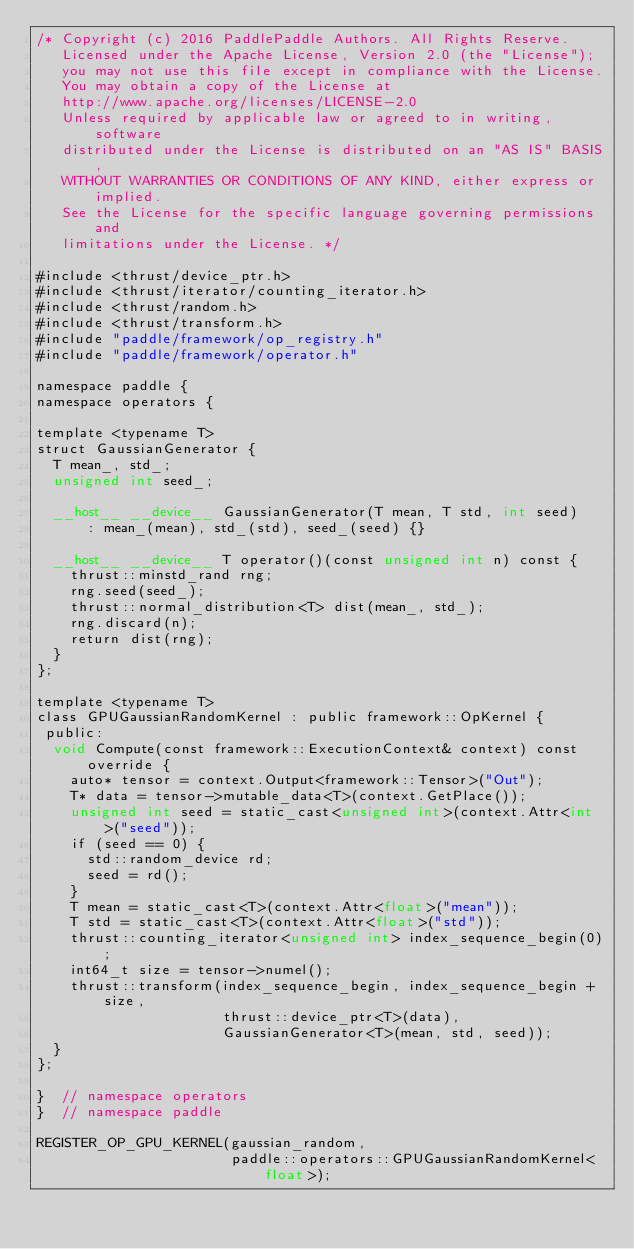<code> <loc_0><loc_0><loc_500><loc_500><_Cuda_>/* Copyright (c) 2016 PaddlePaddle Authors. All Rights Reserve.
   Licensed under the Apache License, Version 2.0 (the "License");
   you may not use this file except in compliance with the License.
   You may obtain a copy of the License at
   http://www.apache.org/licenses/LICENSE-2.0
   Unless required by applicable law or agreed to in writing, software
   distributed under the License is distributed on an "AS IS" BASIS,
   WITHOUT WARRANTIES OR CONDITIONS OF ANY KIND, either express or implied.
   See the License for the specific language governing permissions and
   limitations under the License. */

#include <thrust/device_ptr.h>
#include <thrust/iterator/counting_iterator.h>
#include <thrust/random.h>
#include <thrust/transform.h>
#include "paddle/framework/op_registry.h"
#include "paddle/framework/operator.h"

namespace paddle {
namespace operators {

template <typename T>
struct GaussianGenerator {
  T mean_, std_;
  unsigned int seed_;

  __host__ __device__ GaussianGenerator(T mean, T std, int seed)
      : mean_(mean), std_(std), seed_(seed) {}

  __host__ __device__ T operator()(const unsigned int n) const {
    thrust::minstd_rand rng;
    rng.seed(seed_);
    thrust::normal_distribution<T> dist(mean_, std_);
    rng.discard(n);
    return dist(rng);
  }
};

template <typename T>
class GPUGaussianRandomKernel : public framework::OpKernel {
 public:
  void Compute(const framework::ExecutionContext& context) const override {
    auto* tensor = context.Output<framework::Tensor>("Out");
    T* data = tensor->mutable_data<T>(context.GetPlace());
    unsigned int seed = static_cast<unsigned int>(context.Attr<int>("seed"));
    if (seed == 0) {
      std::random_device rd;
      seed = rd();
    }
    T mean = static_cast<T>(context.Attr<float>("mean"));
    T std = static_cast<T>(context.Attr<float>("std"));
    thrust::counting_iterator<unsigned int> index_sequence_begin(0);
    int64_t size = tensor->numel();
    thrust::transform(index_sequence_begin, index_sequence_begin + size,
                      thrust::device_ptr<T>(data),
                      GaussianGenerator<T>(mean, std, seed));
  }
};

}  // namespace operators
}  // namespace paddle

REGISTER_OP_GPU_KERNEL(gaussian_random,
                       paddle::operators::GPUGaussianRandomKernel<float>);
</code> 